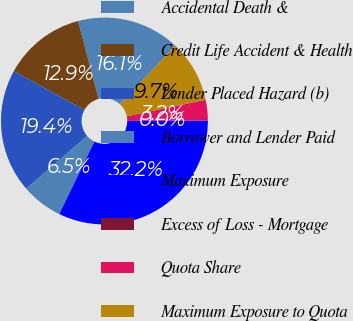Convert chart. <chart><loc_0><loc_0><loc_500><loc_500><pie_chart><fcel>Accidental Death &<fcel>Credit Life Accident & Health<fcel>Lender Placed Hazard (b)<fcel>Borrower and Lender Paid<fcel>Maximum Exposure<fcel>Excess of Loss - Mortgage<fcel>Quota Share<fcel>Maximum Exposure to Quota<nl><fcel>16.13%<fcel>12.9%<fcel>19.35%<fcel>6.46%<fcel>32.24%<fcel>0.01%<fcel>3.23%<fcel>9.68%<nl></chart> 